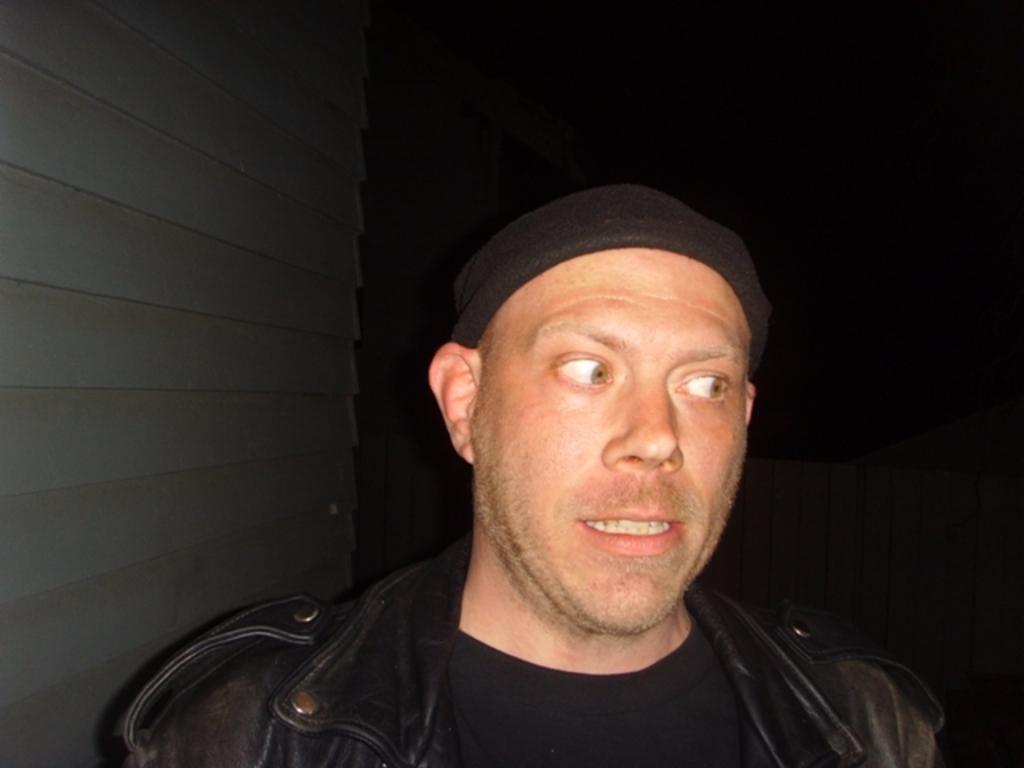Who is present in the image? There is a man in the image. What is the man wearing on his upper body? The man is wearing a black jacket and a black t-shirt. What is the man wearing on his head? The man is wearing a black cap. What can be observed about the background of the image? The background of the image is dark. How many birds are in the flock that is flying over the man's head in the image? There are no birds or flock visible in the image; the man is wearing a black cap. 